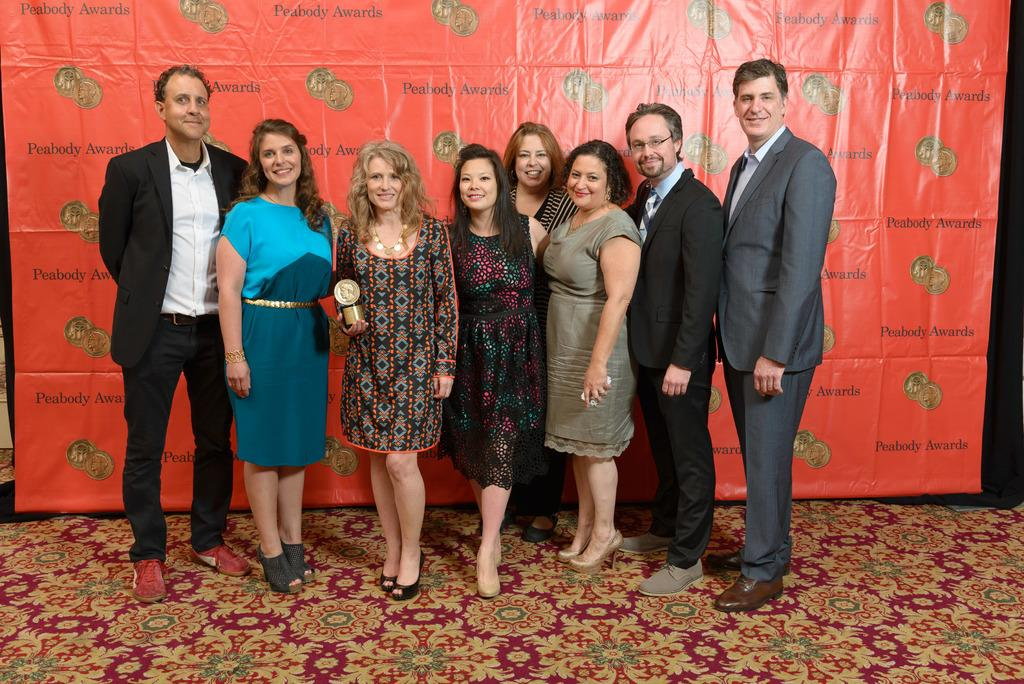What are the people in the image doing? The people in the image are standing and smiling. Can you describe any specific actions or objects in the image? One person is holding an award, and there is a banner visible in the image. What is the name of the person's son who is not present in the image? There is no information about any person's son in the image, so it is impossible to provide a name. 